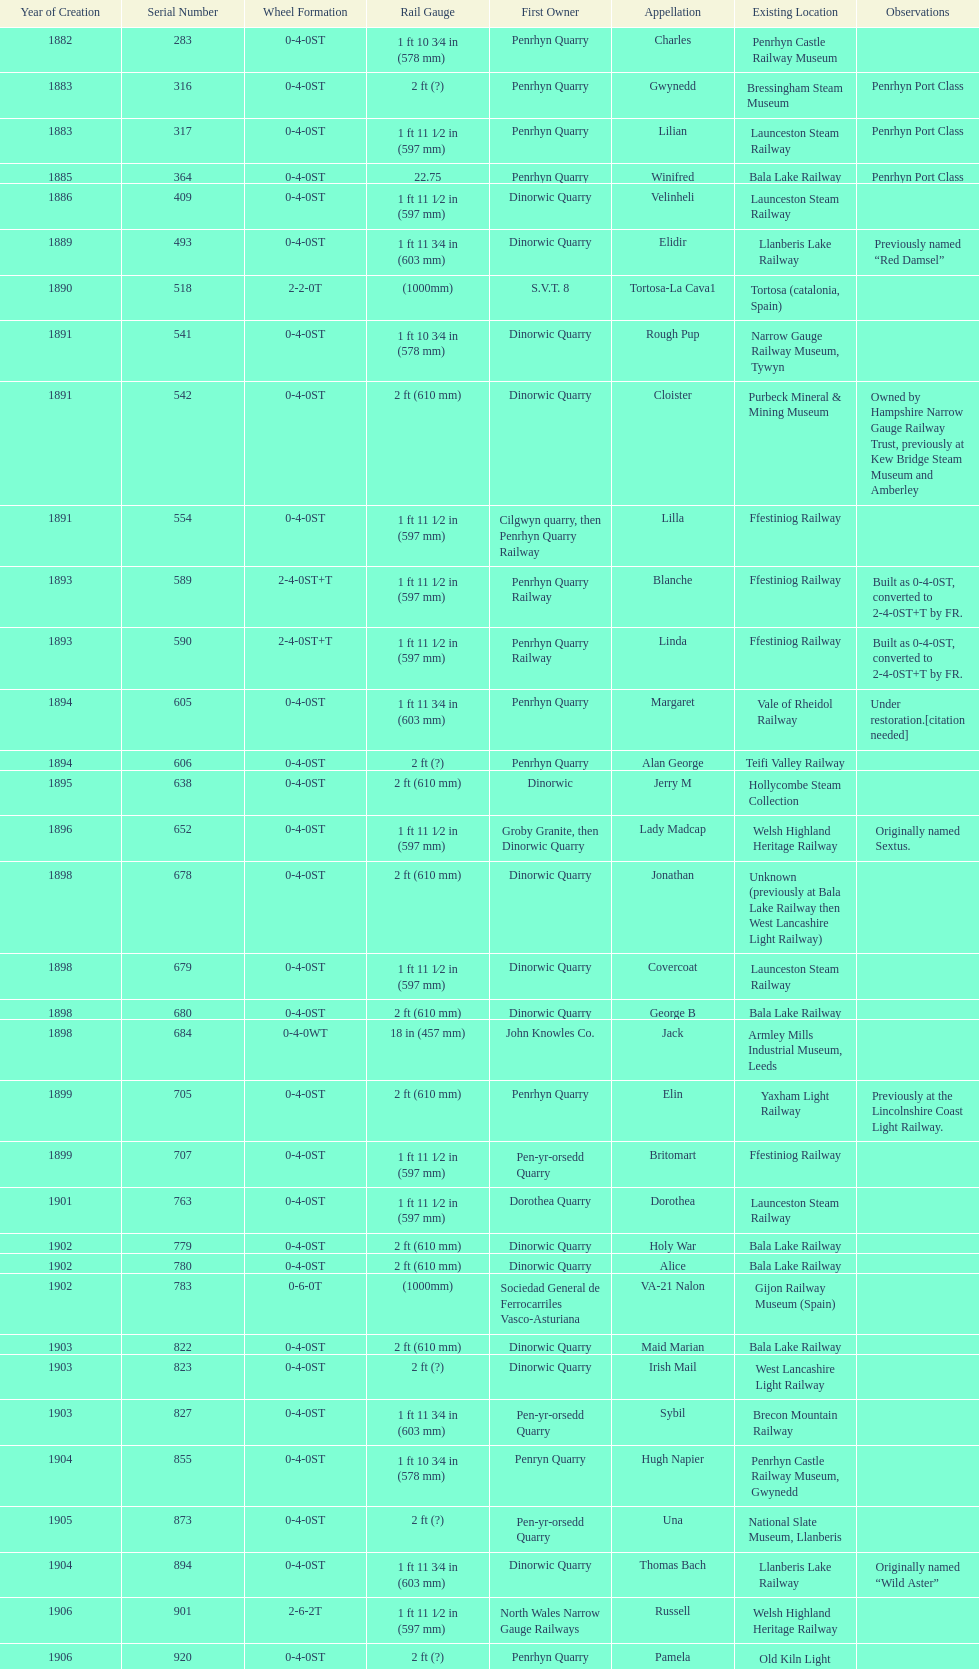How many steam locomotives are currently located at the bala lake railway? 364. 